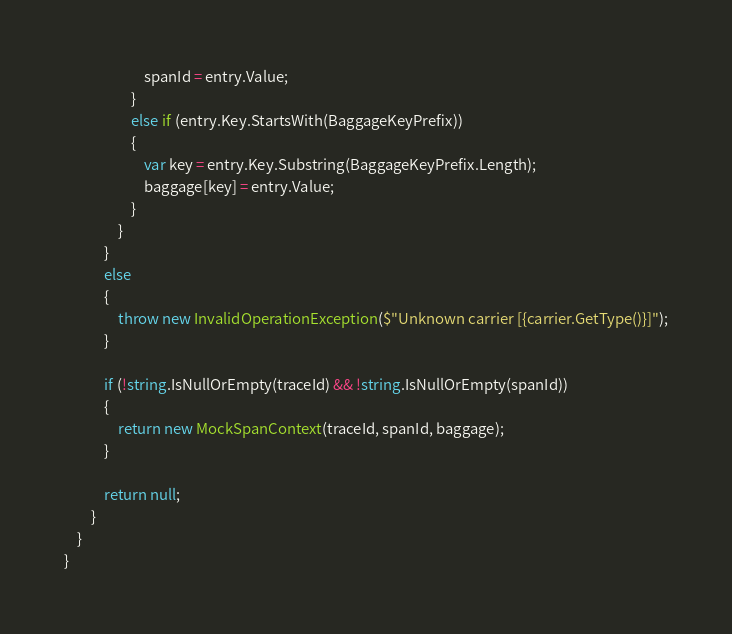Convert code to text. <code><loc_0><loc_0><loc_500><loc_500><_C#_>                        spanId = entry.Value;
                    }
                    else if (entry.Key.StartsWith(BaggageKeyPrefix))
                    {
                        var key = entry.Key.Substring(BaggageKeyPrefix.Length);
                        baggage[key] = entry.Value;
                    }
                }
            }
            else
            {
                throw new InvalidOperationException($"Unknown carrier [{carrier.GetType()}]");
            }

            if (!string.IsNullOrEmpty(traceId) && !string.IsNullOrEmpty(spanId))
            {
                return new MockSpanContext(traceId, spanId, baggage);
            }

            return null;
        }
    }
}
</code> 